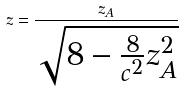Convert formula to latex. <formula><loc_0><loc_0><loc_500><loc_500>z = \frac { z _ { A } } { \sqrt { 8 - \frac { 8 } { c ^ { 2 } } z _ { A } ^ { 2 } } }</formula> 